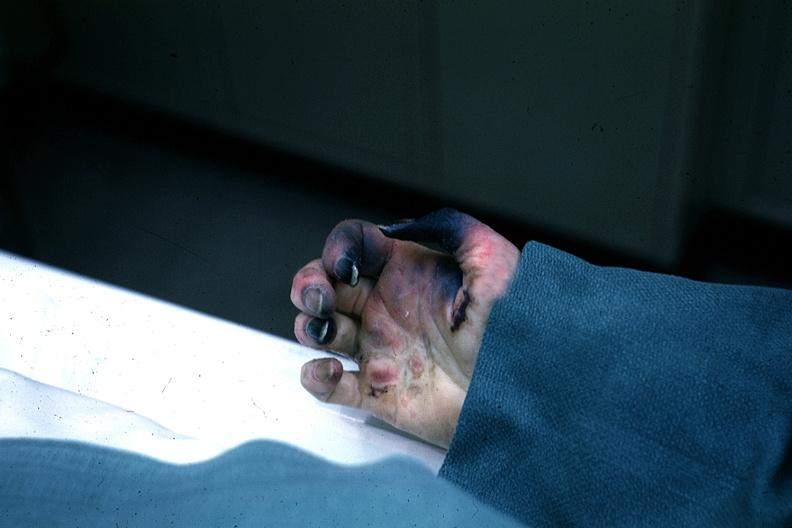why is excellent gangrenous necrosis of fingers said to be?
Answer the question using a single word or phrase. Due embolism 